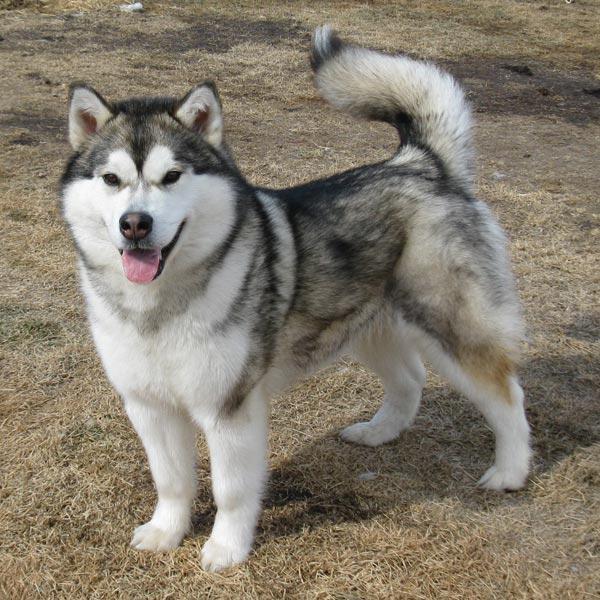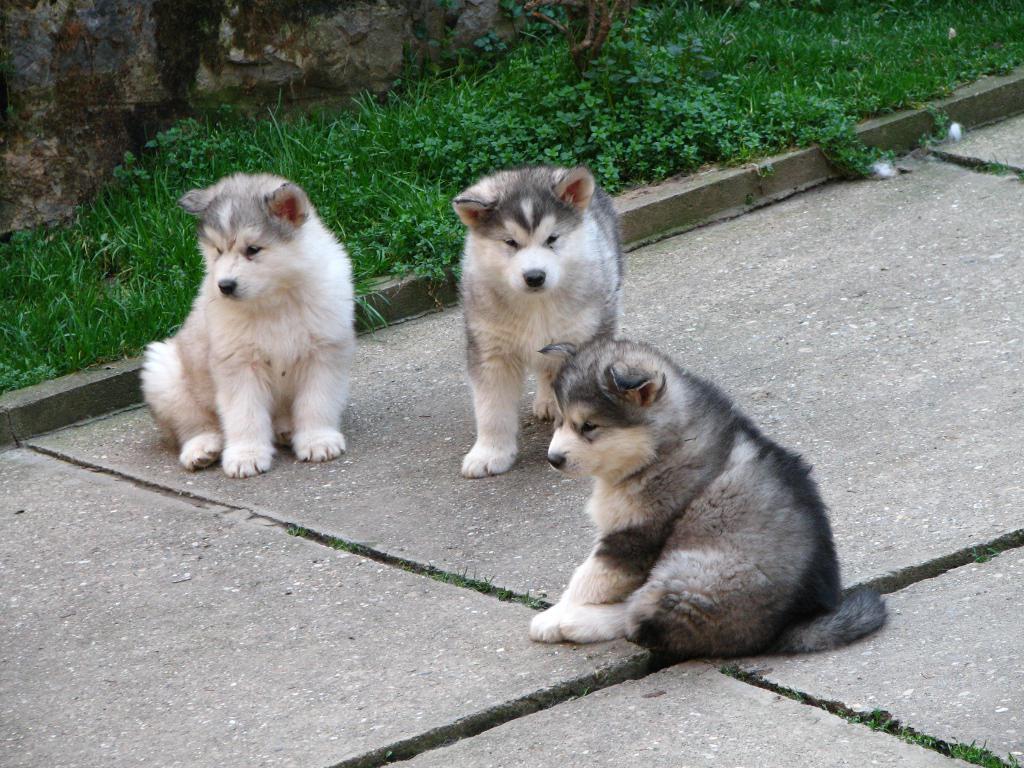The first image is the image on the left, the second image is the image on the right. For the images displayed, is the sentence "There are exactly two dogs with their mouths open." factually correct? Answer yes or no. No. 